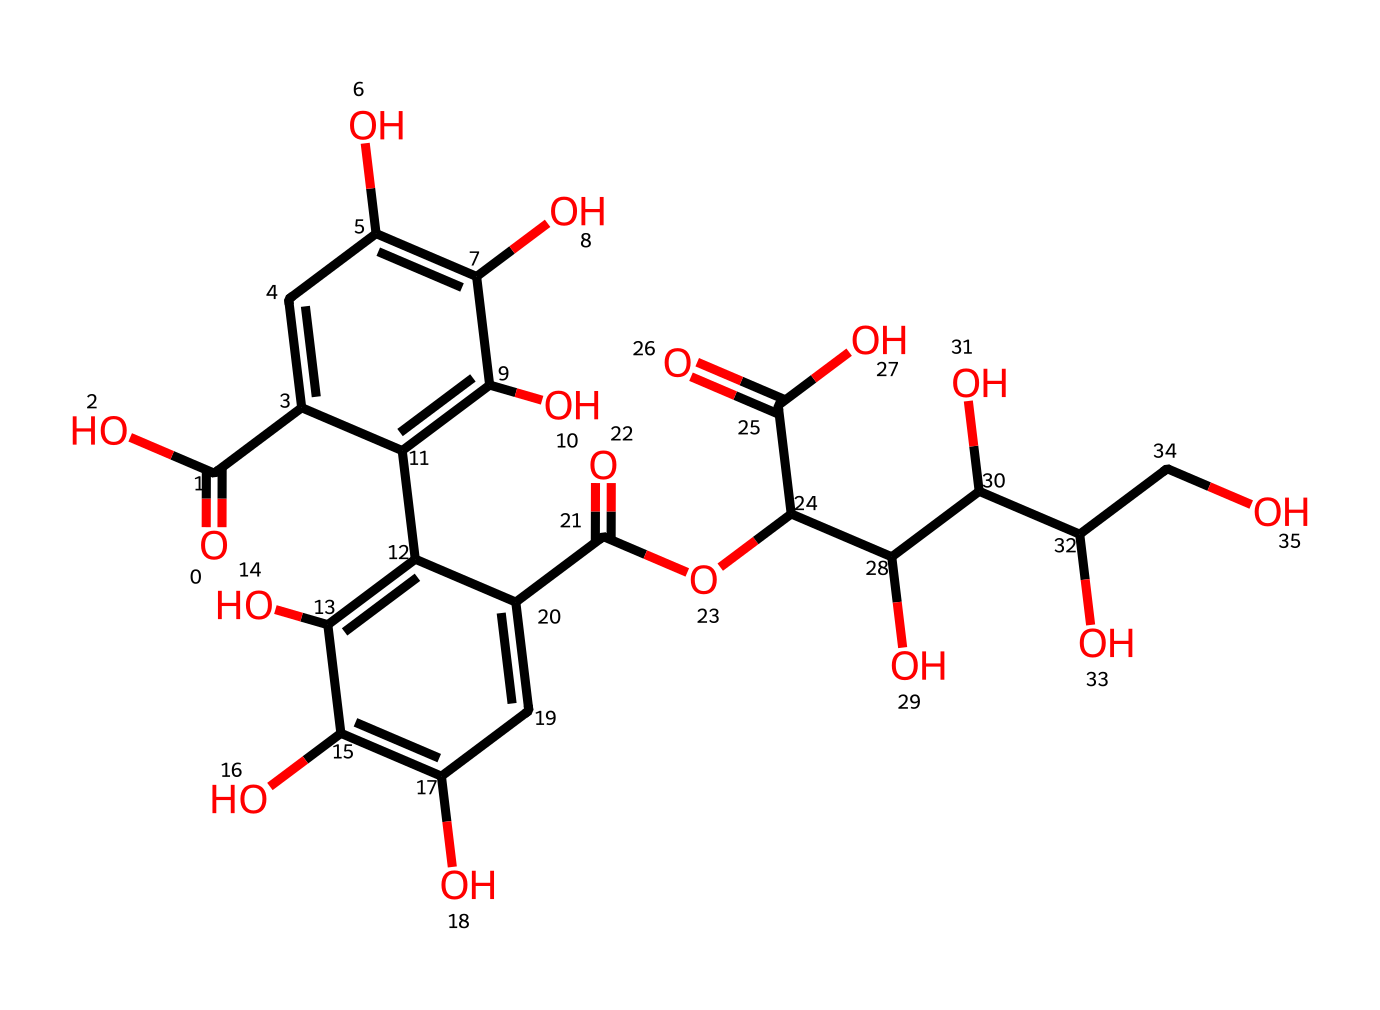what type of functional groups are present in this chemical? The chemical includes carboxylic acid groups (identified by the presence of -COOH), hydroxyl groups (indicated by -OH), and an ester group (noted by -COO-).
Answer: carboxylic acid, hydroxyl, ester how many carbon atoms are present in the structure? Counting the carbon atoms in the provided SMILES, there are a total of 17 carbon atoms in the structure.
Answer: 17 what is the primary color of the dye produced by this chemical? The molecule's structure suggests a brownish color typical of sepia ink, which is a result of its molecular makeup that reflects specific light wavelengths.
Answer: brown how many hydroxyl (-OH) groups are present in the structure? By analyzing the structure, there are 6 hydroxyl groups indicated by the presence of -OH in various positions within the chemical.
Answer: 6 what is the boiling point characteristic of this dye? Due to the presence of multiple functional groups and hydrogen bonds, such dyes typically exhibit a high boiling point, but a precise figure isn't directly calculable from SMILES; however, it's generally above 200 degrees Celsius.
Answer: above 200 degrees Celsius is this dye water-soluble? Given the presence of multiple hydroxyl and carboxylic acid groups, which can interact with water molecules, this dye is expected to be water-soluble.
Answer: yes what type of dye is this compound primarily used for? This compound is primarily used for producing sepia-toned ink, popular in antique-style writing.
Answer: ink 